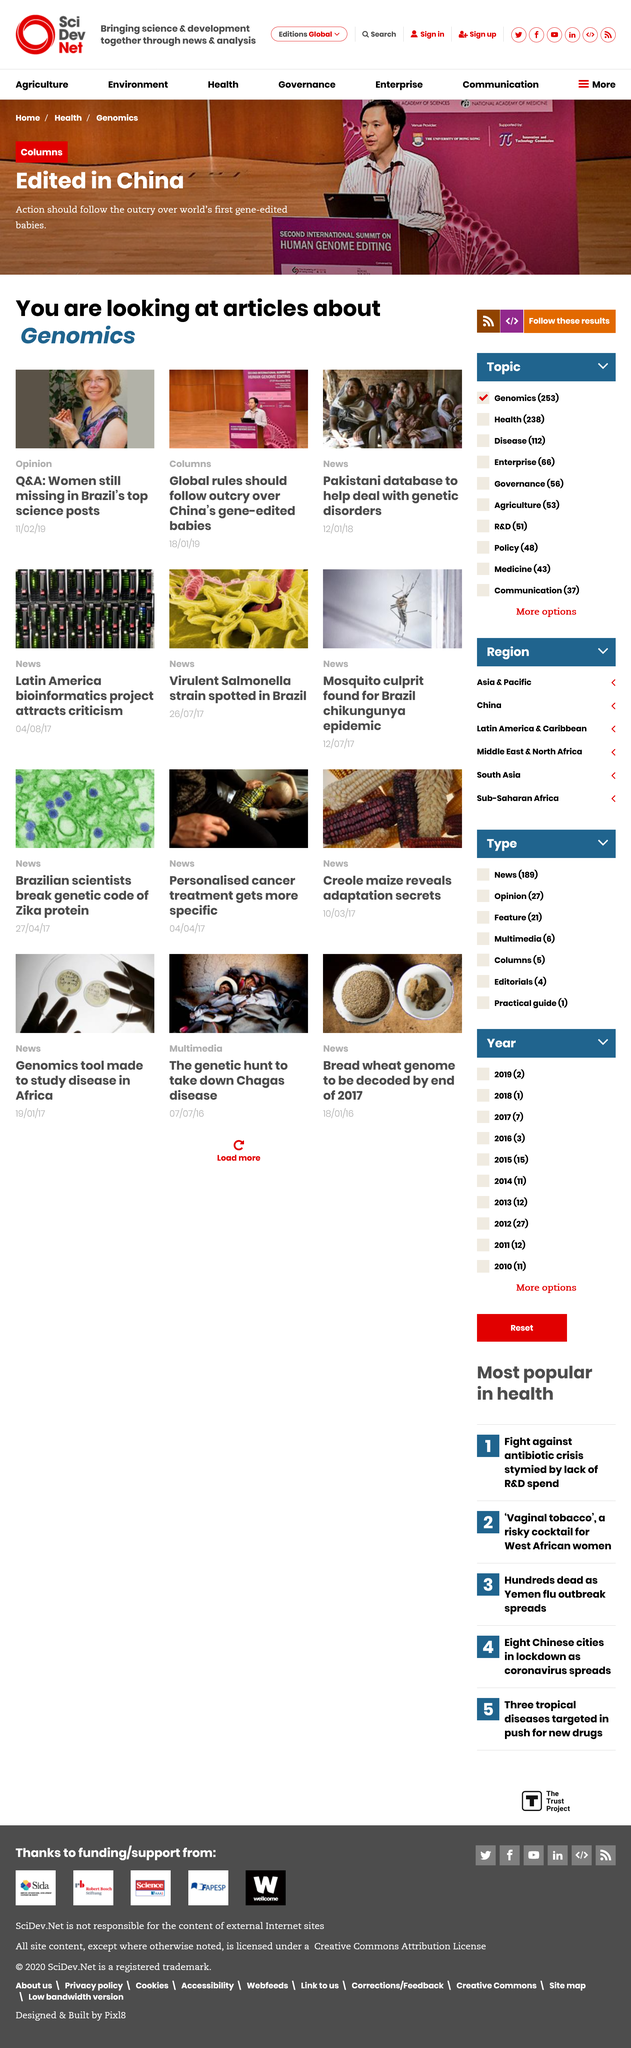Identify some key points in this picture. There is no gender equality in Brazil's top science posts. The articles are about genomics. The attached photos in this page are four in total. 